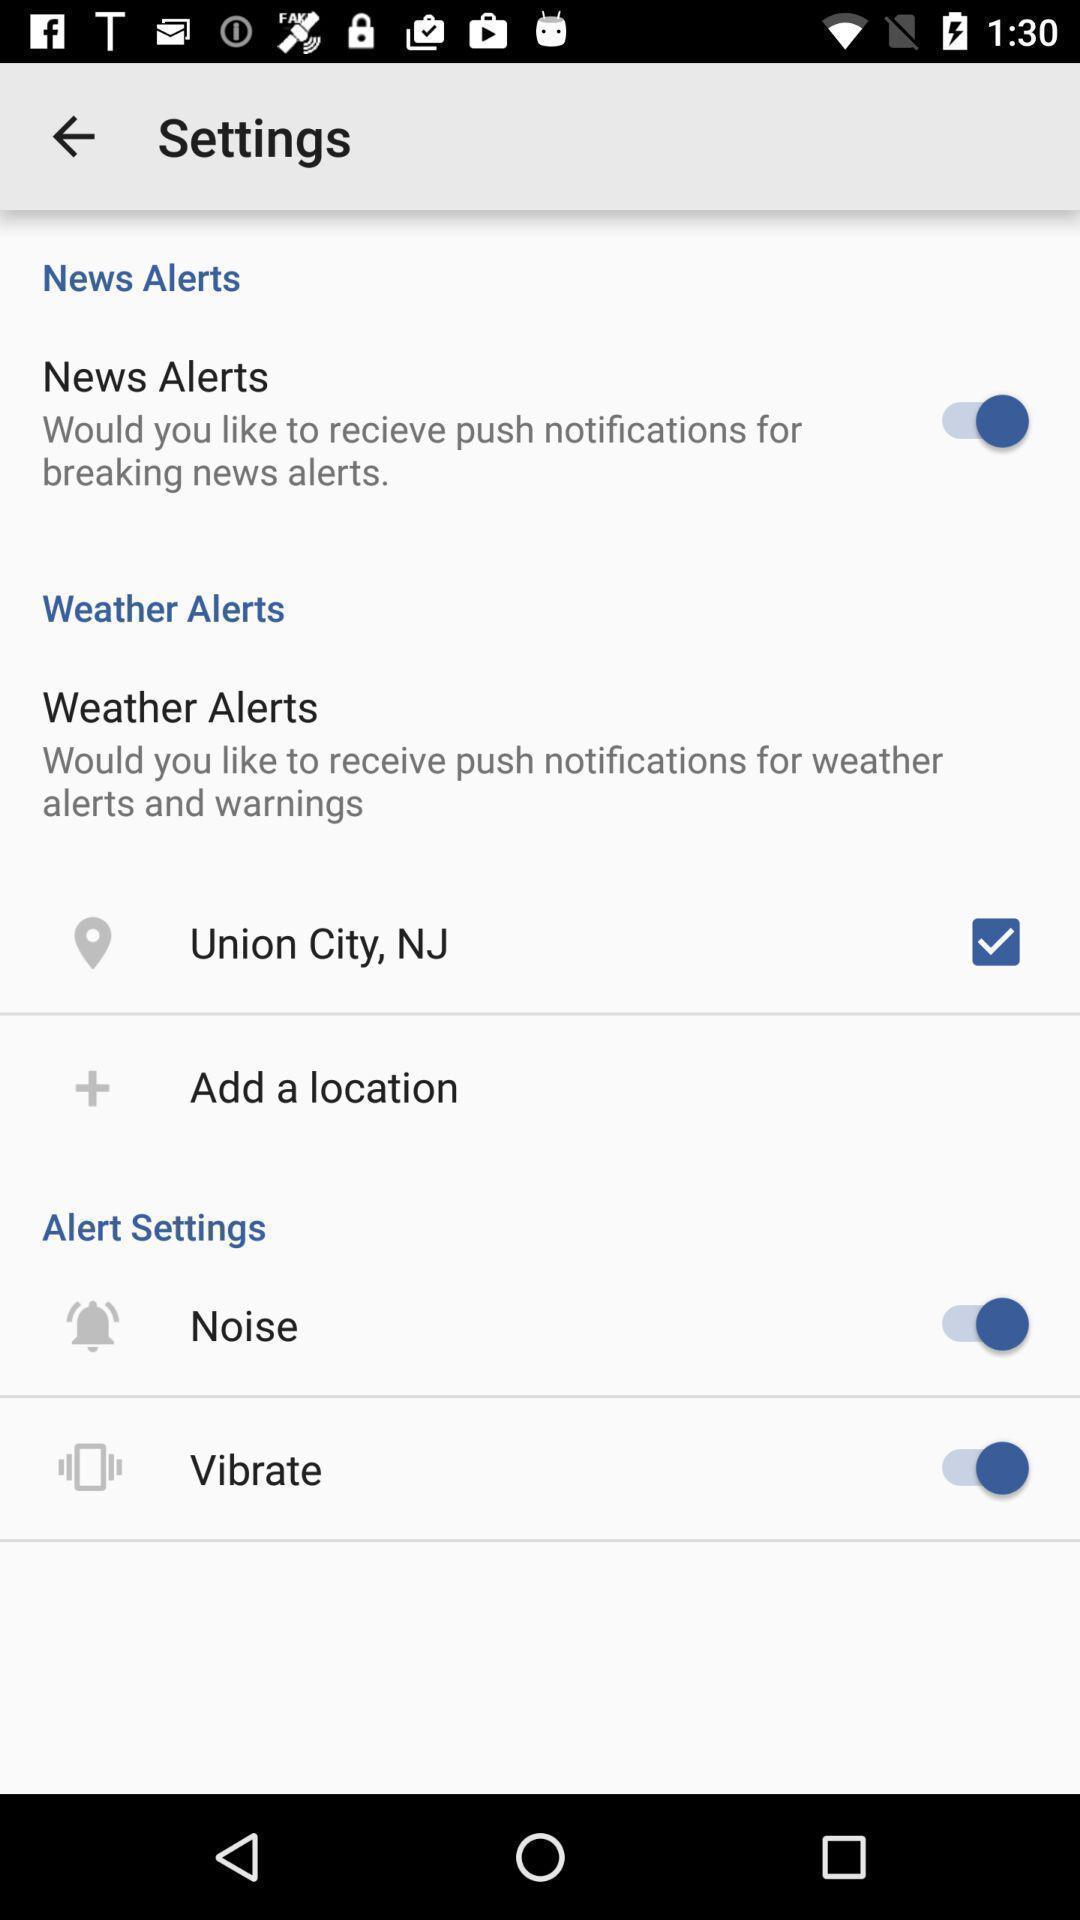Summarize the main components in this picture. Screen displaying list of settings. 